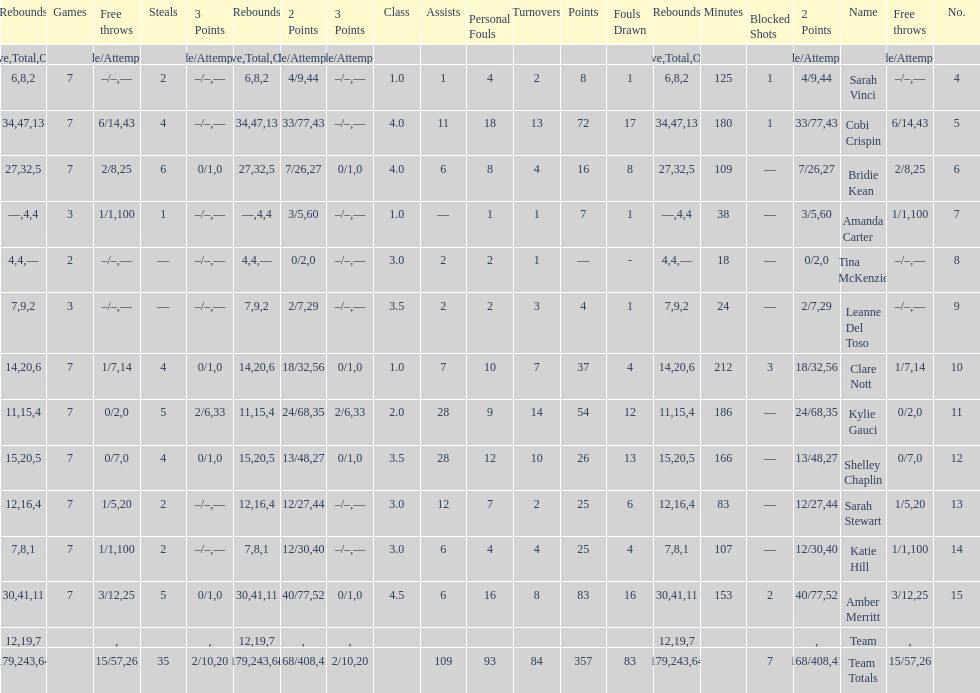Number of 3 points attempted 10. 